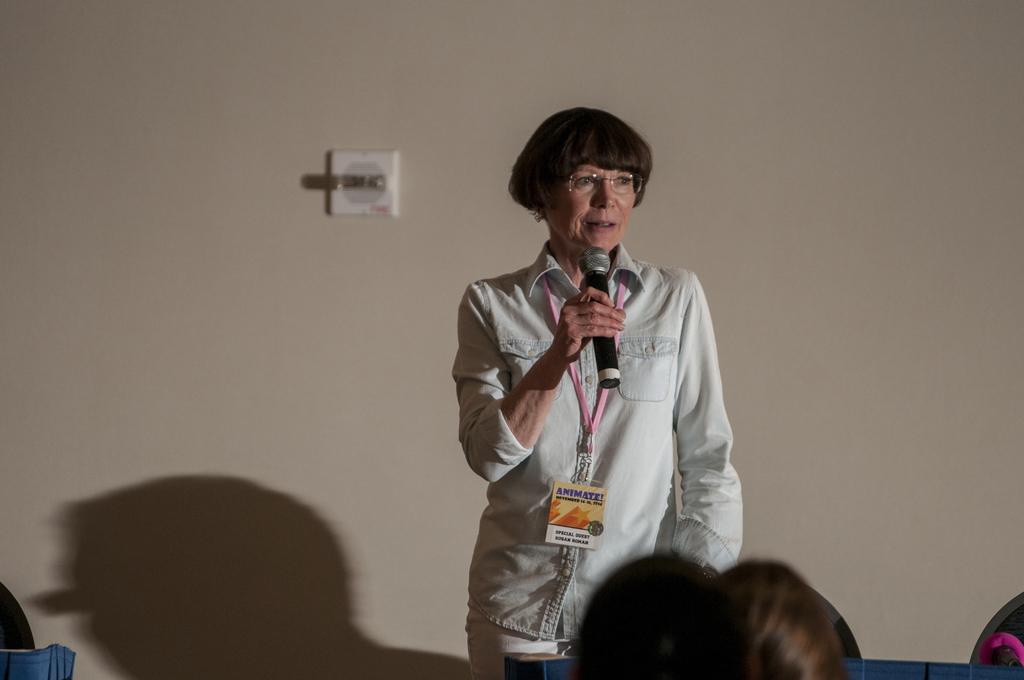Describe this image in one or two sentences. This picture is speaking. She wore shirt and has spectacles, and she is holding a microphone in her right hand. There is a wall behind her and there some people in front of her. 